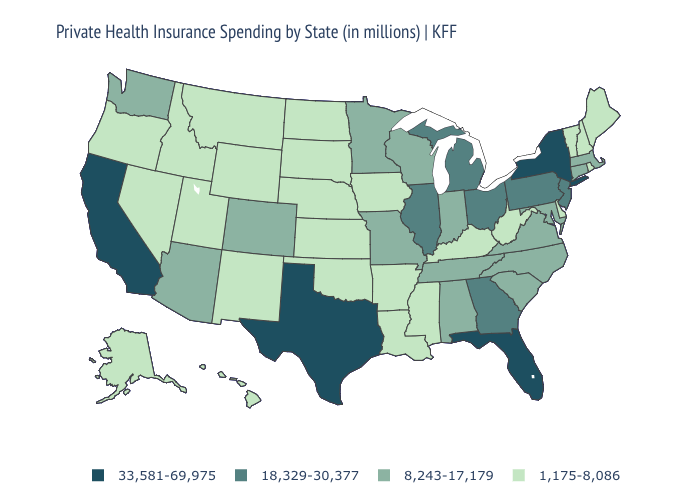Name the states that have a value in the range 18,329-30,377?
Short answer required. Georgia, Illinois, Michigan, New Jersey, Ohio, Pennsylvania. Name the states that have a value in the range 18,329-30,377?
Give a very brief answer. Georgia, Illinois, Michigan, New Jersey, Ohio, Pennsylvania. Name the states that have a value in the range 18,329-30,377?
Give a very brief answer. Georgia, Illinois, Michigan, New Jersey, Ohio, Pennsylvania. Name the states that have a value in the range 8,243-17,179?
Answer briefly. Alabama, Arizona, Colorado, Connecticut, Indiana, Maryland, Massachusetts, Minnesota, Missouri, North Carolina, South Carolina, Tennessee, Virginia, Washington, Wisconsin. Name the states that have a value in the range 33,581-69,975?
Concise answer only. California, Florida, New York, Texas. How many symbols are there in the legend?
Give a very brief answer. 4. What is the lowest value in the MidWest?
Answer briefly. 1,175-8,086. What is the lowest value in the USA?
Write a very short answer. 1,175-8,086. What is the value of Nebraska?
Be succinct. 1,175-8,086. Which states have the lowest value in the MidWest?
Keep it brief. Iowa, Kansas, Nebraska, North Dakota, South Dakota. What is the value of New Mexico?
Concise answer only. 1,175-8,086. Name the states that have a value in the range 8,243-17,179?
Give a very brief answer. Alabama, Arizona, Colorado, Connecticut, Indiana, Maryland, Massachusetts, Minnesota, Missouri, North Carolina, South Carolina, Tennessee, Virginia, Washington, Wisconsin. Does New York have the highest value in the USA?
Quick response, please. Yes. Is the legend a continuous bar?
Short answer required. No. Among the states that border Utah , which have the lowest value?
Write a very short answer. Idaho, Nevada, New Mexico, Wyoming. 